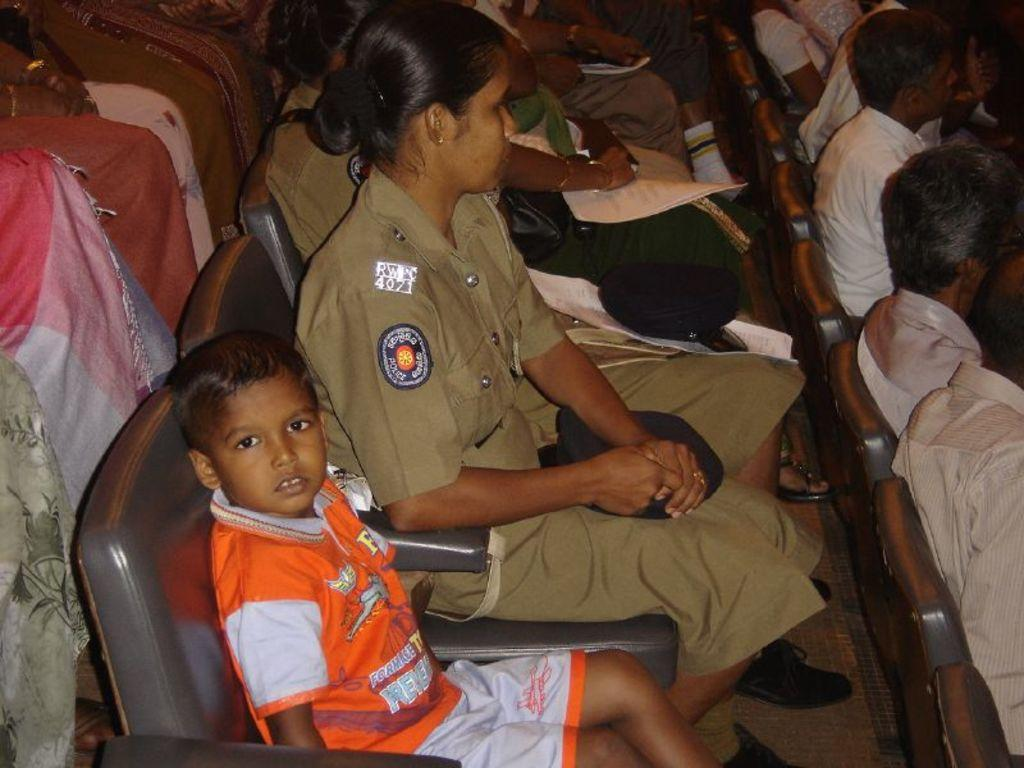What is the main subject of the image? The main subject of the image is a group of people. What are the people in the image doing? The people are sitting on chairs in the image. Can you describe any specific actions or objects being held by the people? Yes, there are people holding papers in the image. What type of club can be seen in the hands of the people in the image? There is no club present in the image; the people are holding papers. What suggestions can be found written on the copper plates in the image? There is no mention of copper plates or any suggestions in the image. 